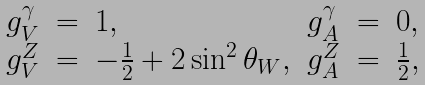Convert formula to latex. <formula><loc_0><loc_0><loc_500><loc_500>\begin{array} { l c l l c l } g _ { V } ^ { \gamma } & = & 1 , & g _ { A } ^ { \gamma } & = & 0 , \\ g _ { V } ^ { Z } & = & - \frac { 1 } { 2 } + 2 \sin ^ { 2 } \theta _ { W } , & g _ { A } ^ { Z } & = & \frac { 1 } { 2 } , \\ \end{array}</formula> 